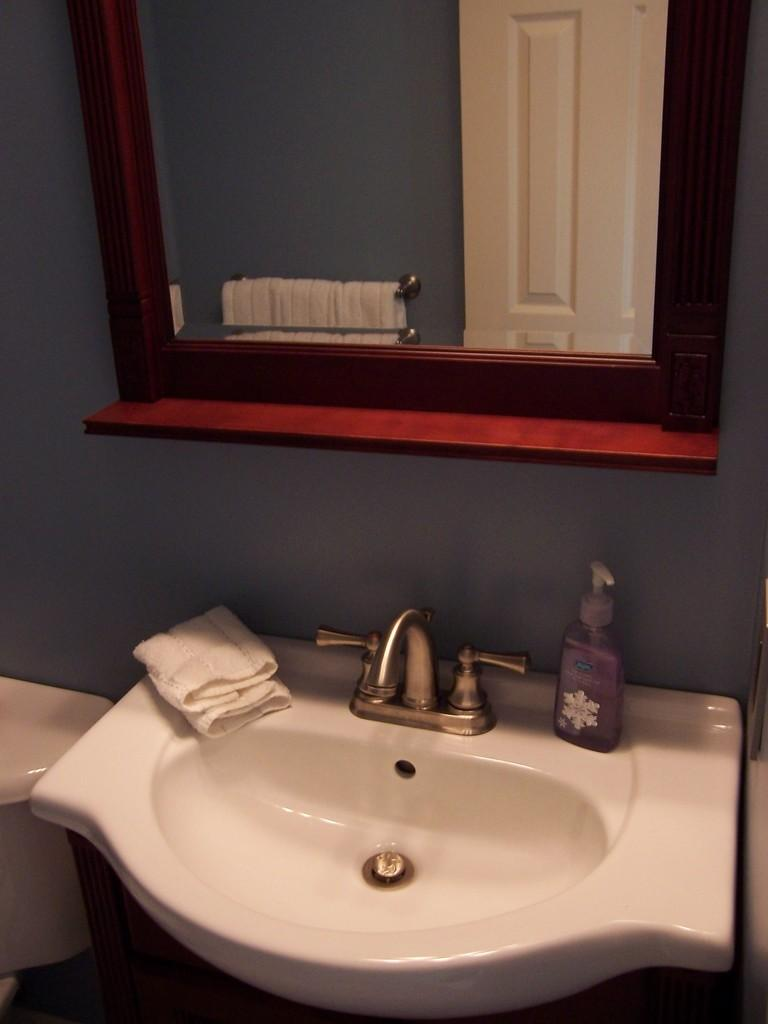What is the main object in the middle of the image? There is a sink in the middle of the image. What is located above the sink? There is a mirror above the sink. Where is the towel placed in relation to the sink? The towel is on the left side of the sink. What is on the right side of the sink? There is a bottle on the right side of the sink. What type of zinc is used to make the sink in the image? There is no information about the material used to make the sink in the image. What type of meal is being prepared in the image? There is no indication of any meal preparation in the image. 